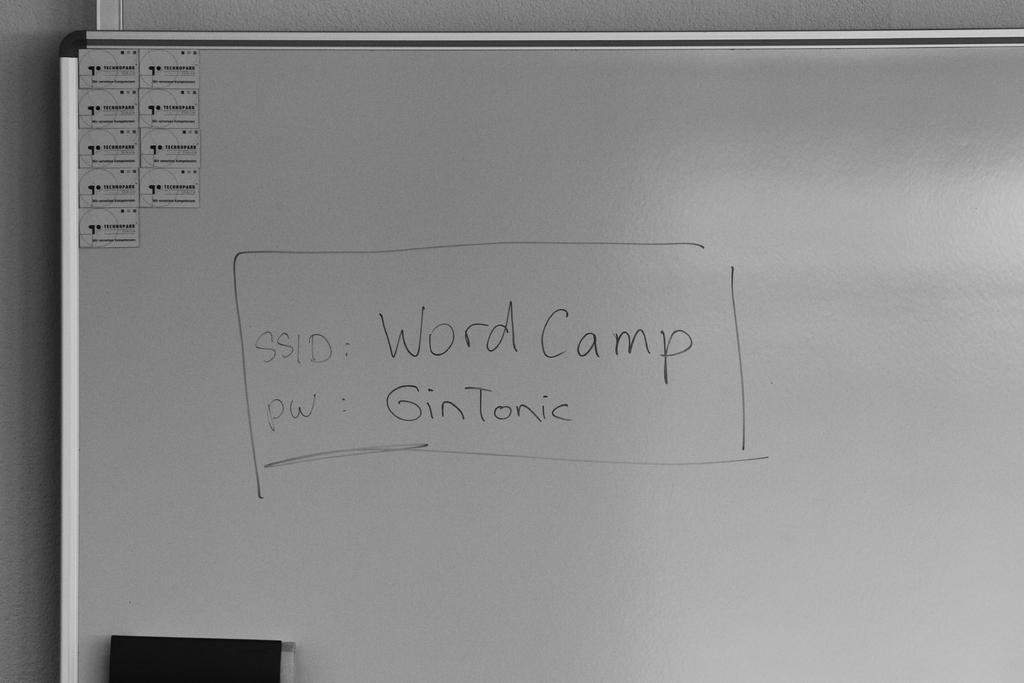What is the password?
Keep it short and to the point. Gintonic. 